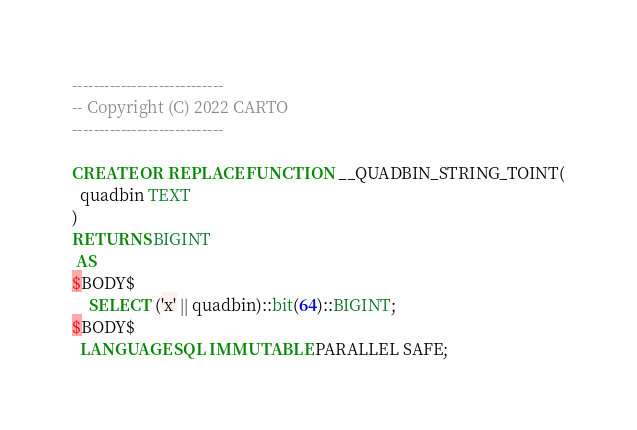Convert code to text. <code><loc_0><loc_0><loc_500><loc_500><_SQL_>----------------------------
-- Copyright (C) 2022 CARTO
----------------------------

CREATE OR REPLACE FUNCTION __QUADBIN_STRING_TOINT(
  quadbin TEXT
)
RETURNS BIGINT
 AS
$BODY$
    SELECT ('x' || quadbin)::bit(64)::BIGINT;
$BODY$
  LANGUAGE SQL IMMUTABLE PARALLEL SAFE;
</code> 